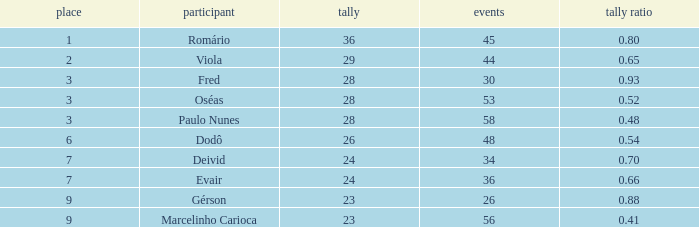How many games have 23 goals with a rank greater than 9? 0.0. 